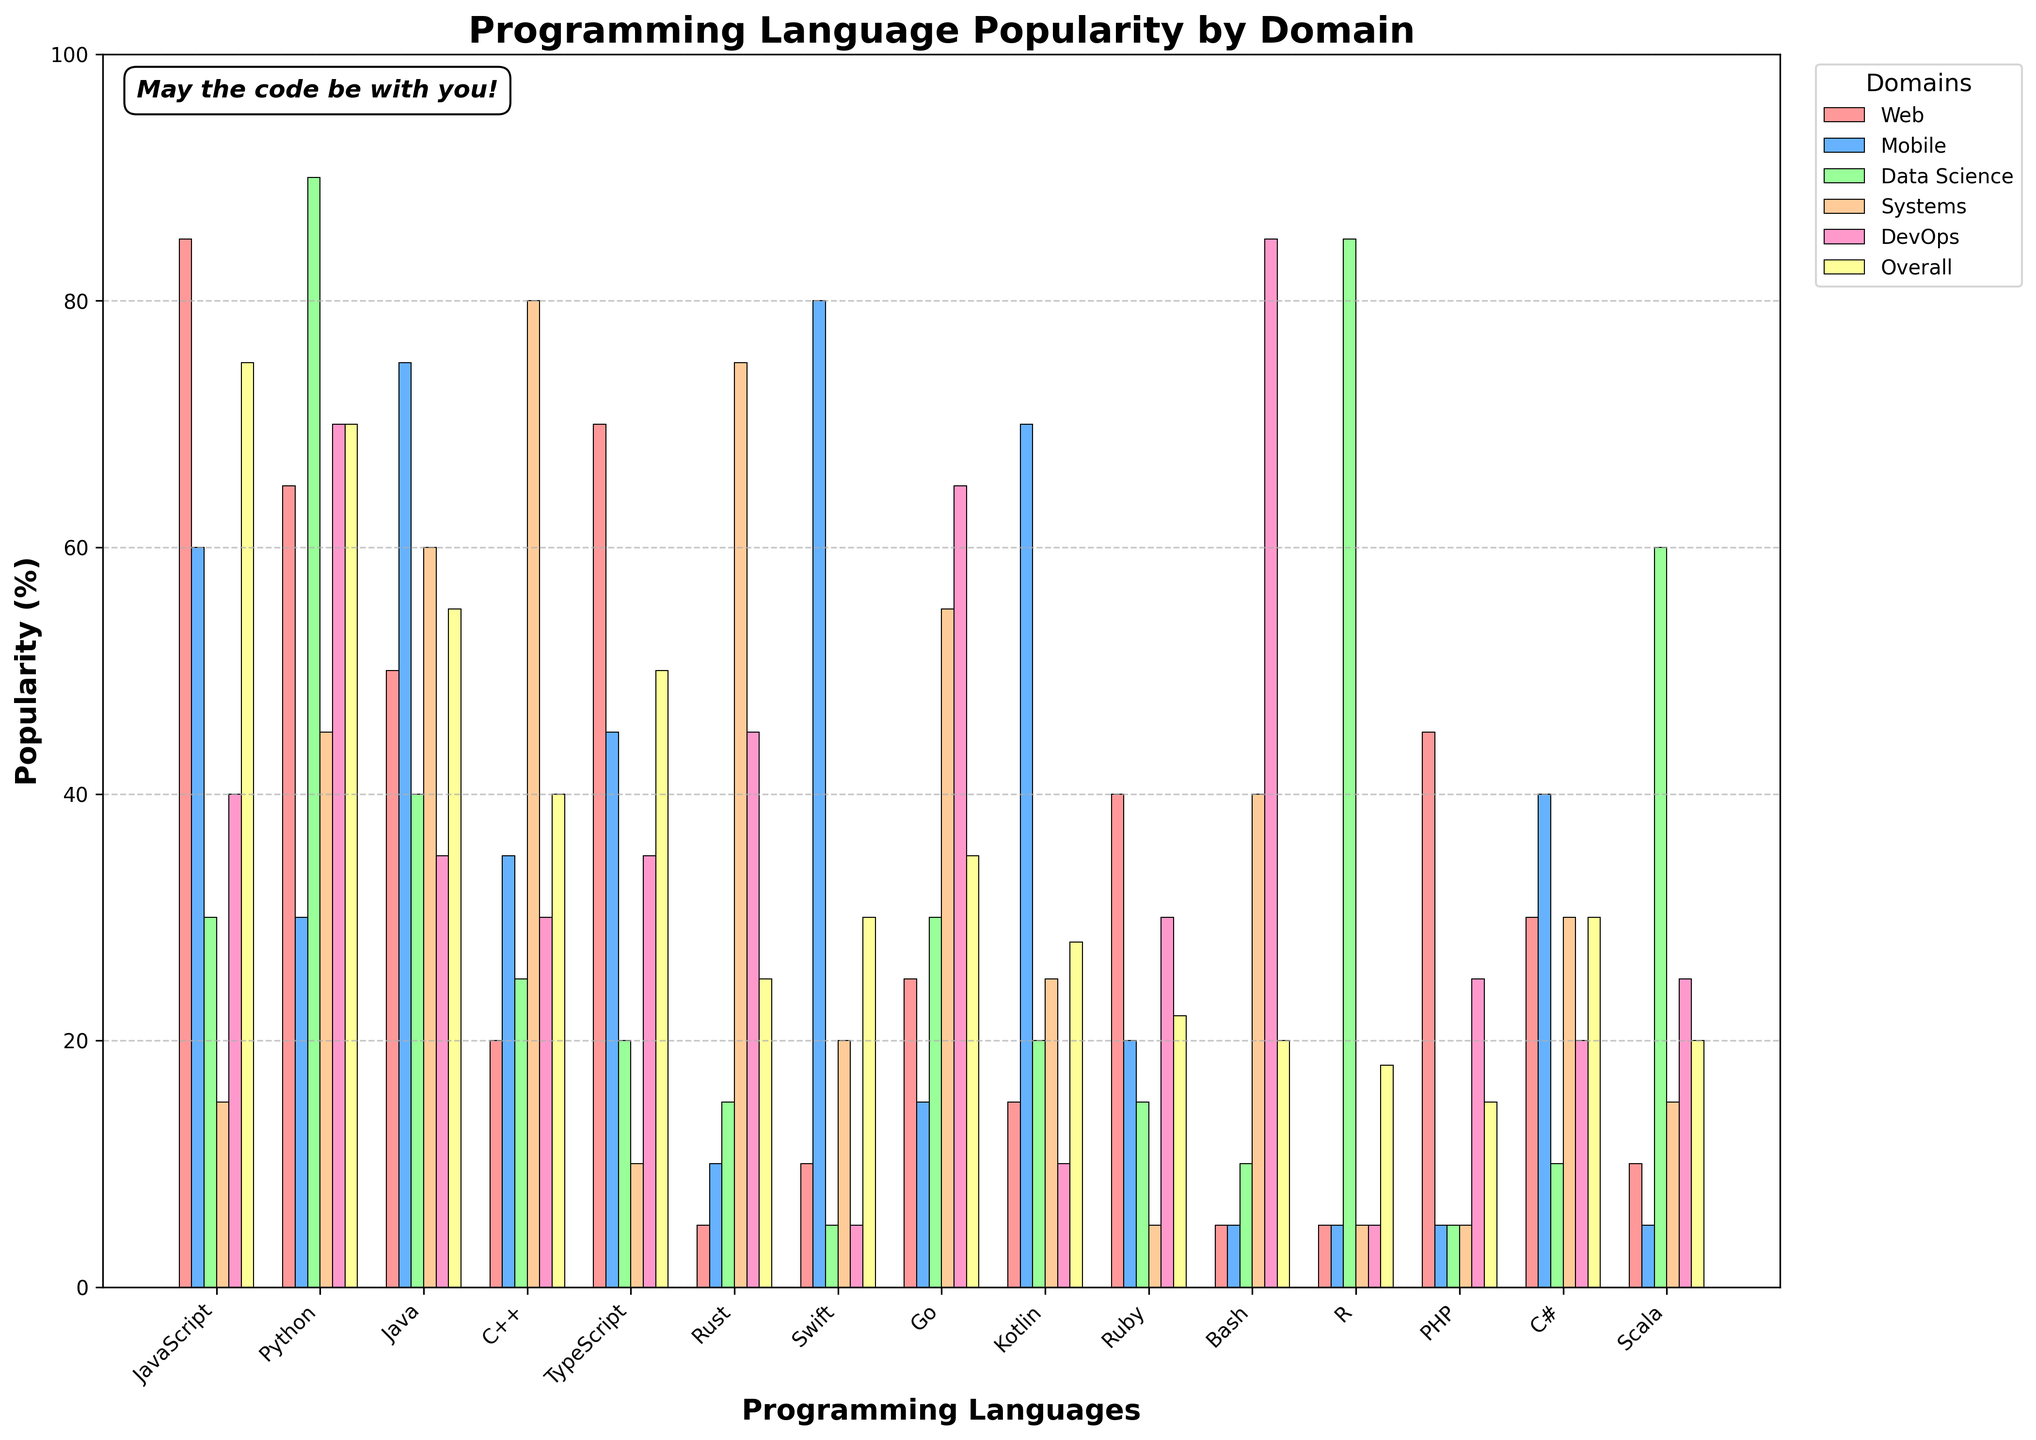What is the most popular programming language overall? The 'Overall' category on the chart shows the popularity percentages of programming languages. By comparing the heights of all the bars in this category, JavaScript has the highest bar, indicating it is the most popular.
Answer: JavaScript Which programming language is more popular in the Data Science domain, Python or Java? Compare the heights of the bars for Python and Java in the 'Data Science' category. The bar for Python is significantly higher than the one for Java, indicating it is more popular in this domain.
Answer: Python In which application domain does Rust have the highest popularity? Look at all the bars for Rust across different domains. The highest bar for Rust is in the 'Systems' category.
Answer: Systems Which language has a higher popularity in the Mobile domain, Kotlin or Swift? Compare the heights of the bars for Kotlin and Swift in the 'Mobile' category. The bar for Swift is higher than the one for Kotlin, making Swift more popular in Mobile.
Answer: Swift What is the sum of popularity percentages for C++ in Systems and DevOps? Find the heights of the bars for C++ in the 'Systems' and 'DevOps' categories. Add the two values: 80 (Systems) + 30 (DevOps) = 110.
Answer: 110 How many domains have Python as the most popular language? Look for the highest bars in each domain category and count how many times Python appears as the tallest bar. Python is the tallest in 'Data Science', 'Systems', and 'DevOps'.
Answer: 3 Is TypeScript more popular than PHP in the Web domain? Compare the heights of the bars for TypeScript and PHP in the 'Web' category. The bar for TypeScript is taller than that for PHP.
Answer: Yes Which language has the least popularity in the Web domain? Look at the smallest bar in the 'Web' category. Rust, Bash, R, and Swift all have the lowest bars with 5%.
Answer: Rust, Bash, R, Swift What is the average popularity of JavaScript across the Web, Mobile, and Data Science domains? Sum up the heights of the bars for JavaScript in the 'Web', 'Mobile', and 'Data Science' categories: 85 (Web) + 60 (Mobile) + 30 (Data Science) = 175. There are 3 domains, so the average is 175 / 3 ≈ 58.3.
Answer: 58.3 Compared to Go, how much more popular is Python in the DevOps domain? In the 'DevOps' category, identify the bar heights for Python and Go. Subtract the popularity of Go from that of Python: 70 (Python) - 65 (Go) = 5.
Answer: 5 